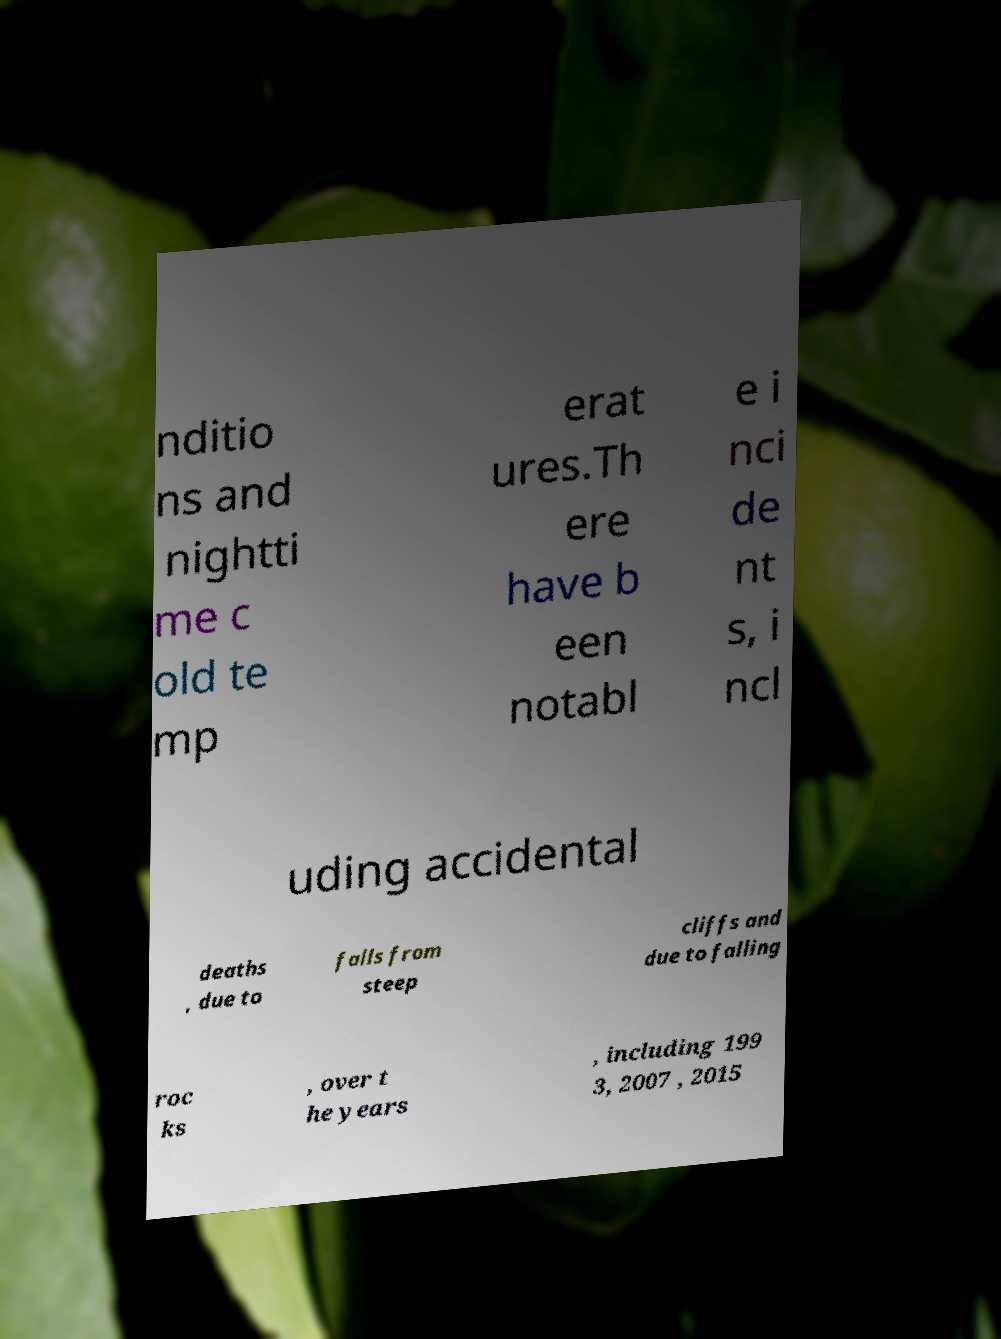Could you assist in decoding the text presented in this image and type it out clearly? nditio ns and nightti me c old te mp erat ures.Th ere have b een notabl e i nci de nt s, i ncl uding accidental deaths , due to falls from steep cliffs and due to falling roc ks , over t he years , including 199 3, 2007 , 2015 